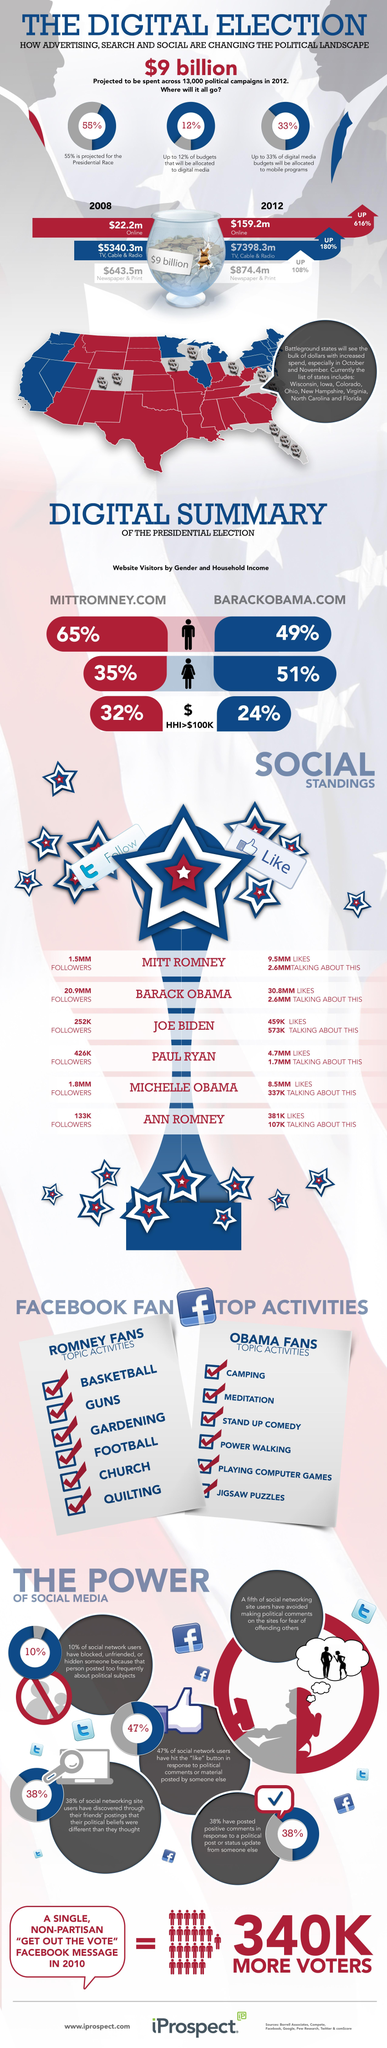Outline some significant characteristics in this image. According to the data, during the presidential election, 65% of males visited the website 'MITTROMNEY.COM'. Mitt Romney received approximately 9.5 million Facebook likes during the presidential election. In the presidential election, Barack Obama had 20.9 million people following him on Twitter. During the presidential election, 51% of females visited the website "BARACKOBAMA.COM. 